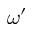Convert formula to latex. <formula><loc_0><loc_0><loc_500><loc_500>\omega ^ { \prime }</formula> 